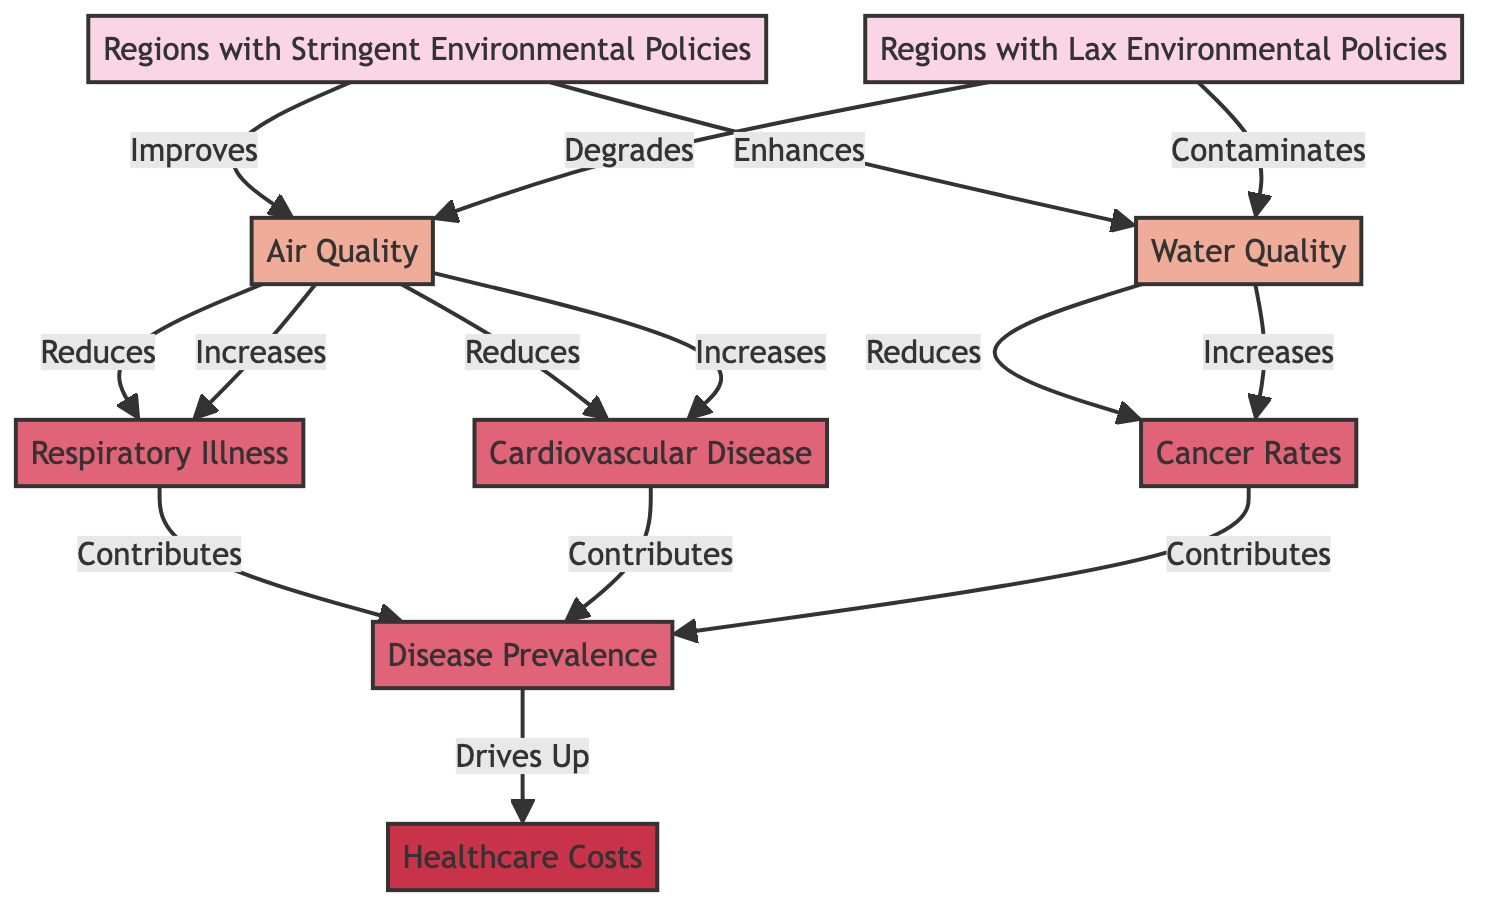What are the two types of environmental policies depicted? The diagram shows two types of environmental policies: "Regions with Stringent Environmental Policies" and "Regions with Lax Environmental Policies." Both are labeled clearly at the top of the diagram.
Answer: Stringent and Lax How does stringent environmental policy affect air quality? According to the diagram, stringent policies lead to an improvement in air quality, as indicated by the directed arrow from "Regions with Stringent Environmental Policies" to "Air Quality" that states "Improves."
Answer: Improves What diseases are reduced by improved air quality? The diagram indicates that improved air quality reduces both respiratory illness and cardiovascular disease, as shown by the arrows going from "Air Quality" to these disease nodes which state "Reduces."
Answer: Respiratory illness and cardiovascular disease What impact do lax environmental policies have on water quality? The diagram indicates that lax policies contaminate water quality, as shown by the directed arrow from "Regions with Lax Environmental Policies" to "Water Quality" labeled "Contaminates."
Answer: Contaminates What does disease prevalence drive up in the healthcare system? The diagram illustrates that disease prevalence drives up healthcare costs, as shown by the directed arrow from "Disease Prevalence" to "Healthcare Costs" labeled "Drives Up."
Answer: Healthcare Costs How many disease types are mentioned in the diagram? The diagram lists three disease types: respiratory illness, cardiovascular disease, and cancer rates. Each node is explicitly labeled in the disease section.
Answer: Three What does improved water quality reduce? The diagram shows that improved water quality reduces cancer rates, indicated by the arrow pointing from "Water Quality" to "Cancer Rates" that says "Reduces."
Answer: Cancer Rates How do lax policies affect disease prevalence? The diagram suggests that the degradation of air and water quality due to lax policies contributes to increased disease prevalence, which can be inferred from the negative relationships displayed in the flowchart.
Answer: Increases Which node contributes the most to disease prevalence? The nodes respiratory illness, cardiovascular disease, and cancer rates all contribute to disease prevalence, as shown by the arrows leading into the "Disease Prevalence" node, meaning each contributes equally.
Answer: Equal contribution 